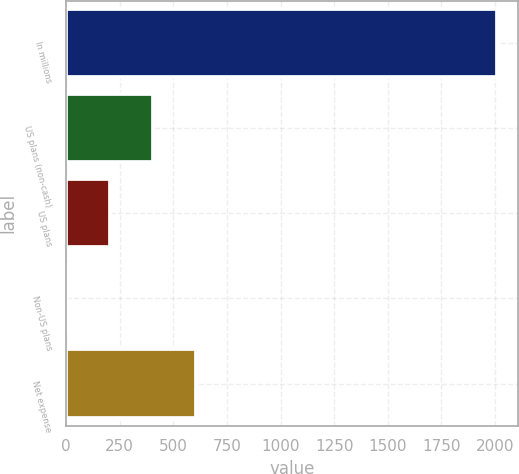<chart> <loc_0><loc_0><loc_500><loc_500><bar_chart><fcel>In millions<fcel>US plans (non-cash)<fcel>US plans<fcel>Non-US plans<fcel>Net expense<nl><fcel>2009<fcel>404.2<fcel>203.6<fcel>3<fcel>604.8<nl></chart> 